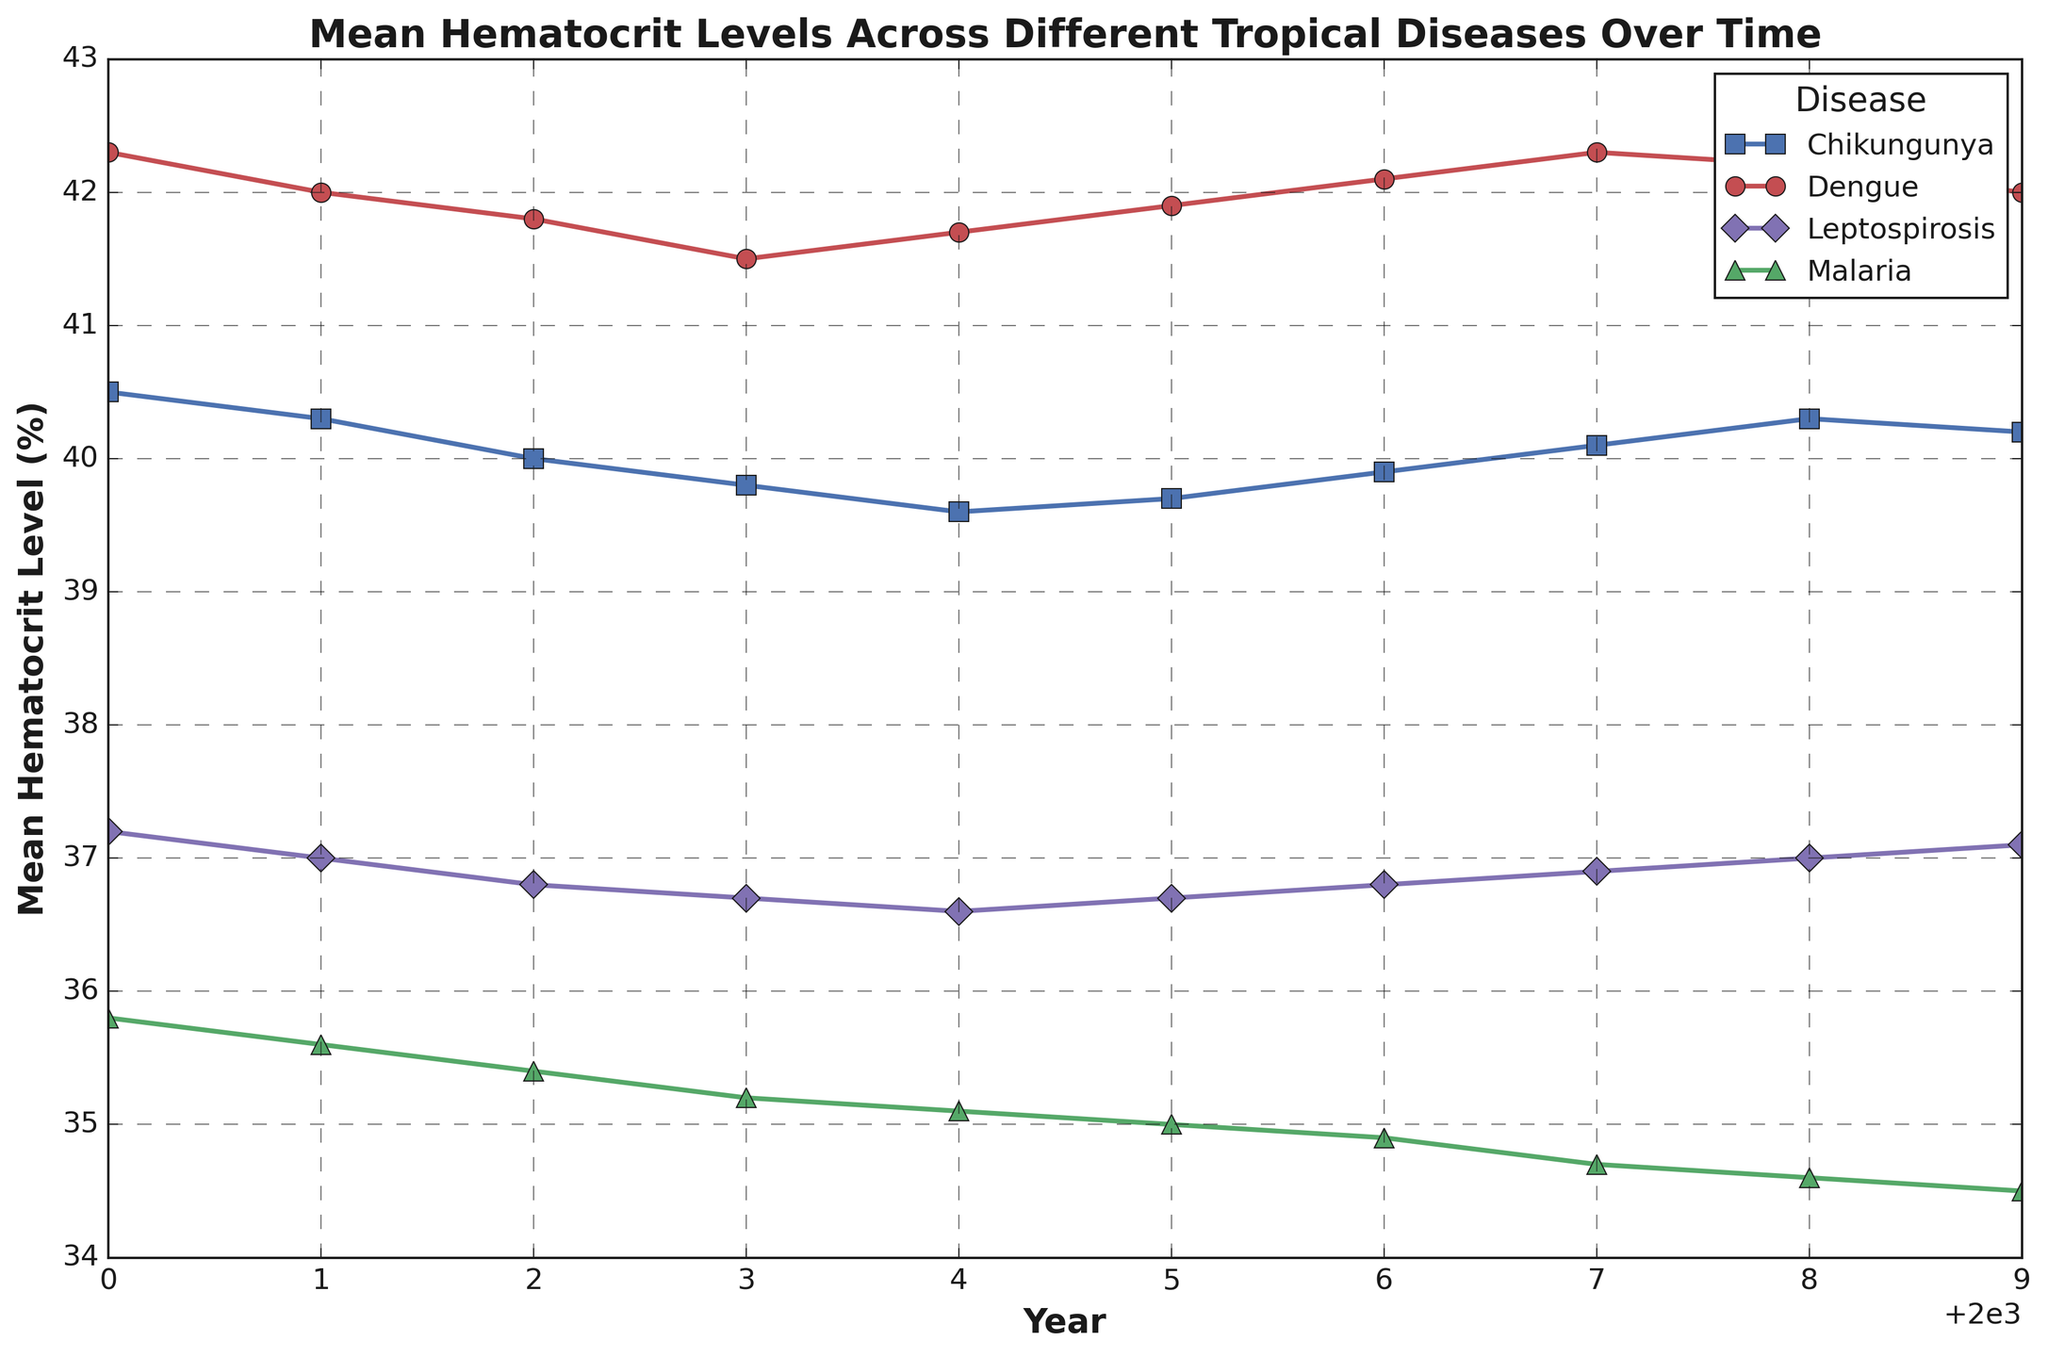What is the overall trend of hematocrit levels for Dengue from 2000 to 2009? The plot shows the mean hematocrit levels for Dengue over the years 2000 to 2009. By observing the line, we can see that the levels start at 42.3% in 2000, slightly decrease until reaching a low of 41.5% in 2003, and then gradually increase back to 42.3% by 2007, ending at 42.0% in 2009.
Answer: Decreasing and then increasing Which disease had the highest mean hematocrit level in 2006? By observing the plot, we can compare the mean hematocrit levels of different diseases in 2006. Dengue and Chikungunya had mean levels of approximately 42.1% and 39.9% respectively, while Malaria had about 34.9% and Leptospirosis had around 36.8%. Dengue has the highest level among all.
Answer: Dengue What is the difference in mean hematocrit levels between Chikungunya and Malaria in the year 2004? From the plot, the mean hematocrit level for Chikungunya in 2004 is around 39.6%, and for Malaria, it is approximately 35.1%. The difference can be calculated as 39.6% - 35.1% = 4.5%.
Answer: 4.5% Between which two consecutive years did Leptospirosis see the highest increase in mean hematocrit levels? Observing the plot for Leptospirosis, the mean hematocrit levels increase from 36.6% in 2004 to 36.7% in 2005, 0.1% each year until 2007, and have a consistent level of increase. However, from 2000 to 2001, there is a steeper increase, indicating that 2000 to 2001 had higher jumps compared to others.
Answer: 2000 to 2001 How did the mean hematocrit levels of Malaria change over the period? The plot shows that the mean hematocrit levels of Malaria gradually decrease from 2000 (35.8%) to 2009 (34.5%), showing a steady downward trend.
Answer: Decreasing Which disease shows a U-shaped trend in its mean hematocrit levels from 2000 to 2009? Observing the plot, Dengue shows a U-shaped trend where the hematocrit levels decrease from 2000 to 2003 and then increase back till 2007 before stabilizing.
Answer: Dengue Among all diseases, which one had the lowest mean hematocrit level in 2009? Comparing all the mean hematocrit levels for each disease in 2009, Malaria has the lowest value with approximately 34.5%.
Answer: Malaria What was the average mean hematocrit level for Chikungunya between 2005 and 2009? From the plot, extract the mean hematocrit levels for Chikungunya from 2005 to 2009, which are 39.7%, 39.9%, 40.1%, 40.3%, and 40.2%. Calculate the average: (39.7 + 39.9 + 40.1 + 40.3 + 40.2)/5 = 40.04%.
Answer: 40.04% Which disease shows the most consistent mean hematocrit levels over the span of 2000 to 2009? Observing each disease's plot, Leptospirosis has the most consistent mean hematocrit levels, with minimal changes from 37.2% in 2000 to 37.1% in 2009.
Answer: Leptospirosis 